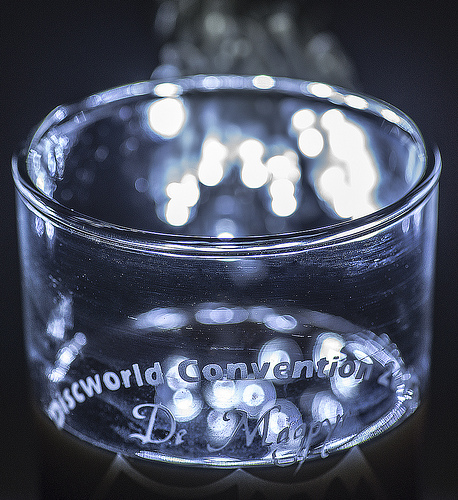<image>
Is the light on the votive? No. The light is not positioned on the votive. They may be near each other, but the light is not supported by or resting on top of the votive. 